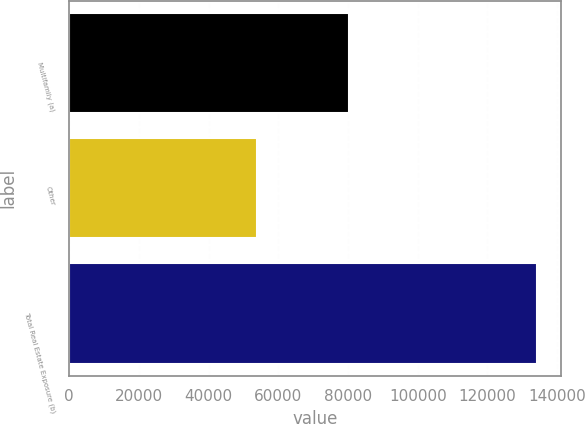Convert chart. <chart><loc_0><loc_0><loc_500><loc_500><bar_chart><fcel>Multifamily (a)<fcel>Other<fcel>Total Real Estate Exposure (b)<nl><fcel>80314<fcel>53973<fcel>134287<nl></chart> 